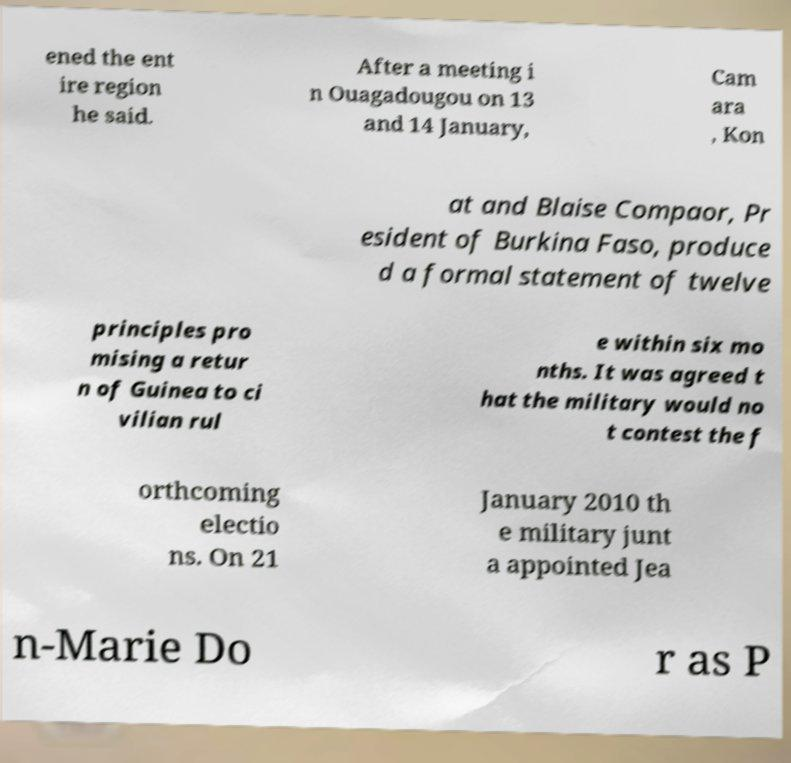Please identify and transcribe the text found in this image. ened the ent ire region he said. After a meeting i n Ouagadougou on 13 and 14 January, Cam ara , Kon at and Blaise Compaor, Pr esident of Burkina Faso, produce d a formal statement of twelve principles pro mising a retur n of Guinea to ci vilian rul e within six mo nths. It was agreed t hat the military would no t contest the f orthcoming electio ns. On 21 January 2010 th e military junt a appointed Jea n-Marie Do r as P 